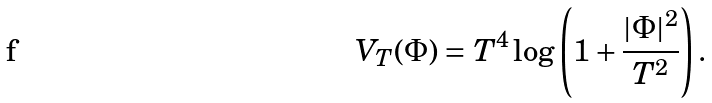<formula> <loc_0><loc_0><loc_500><loc_500>V _ { T } ( \Phi ) = T ^ { 4 } \log \left ( 1 + \frac { | \Phi | ^ { 2 } } { T ^ { 2 } } \right ) .</formula> 